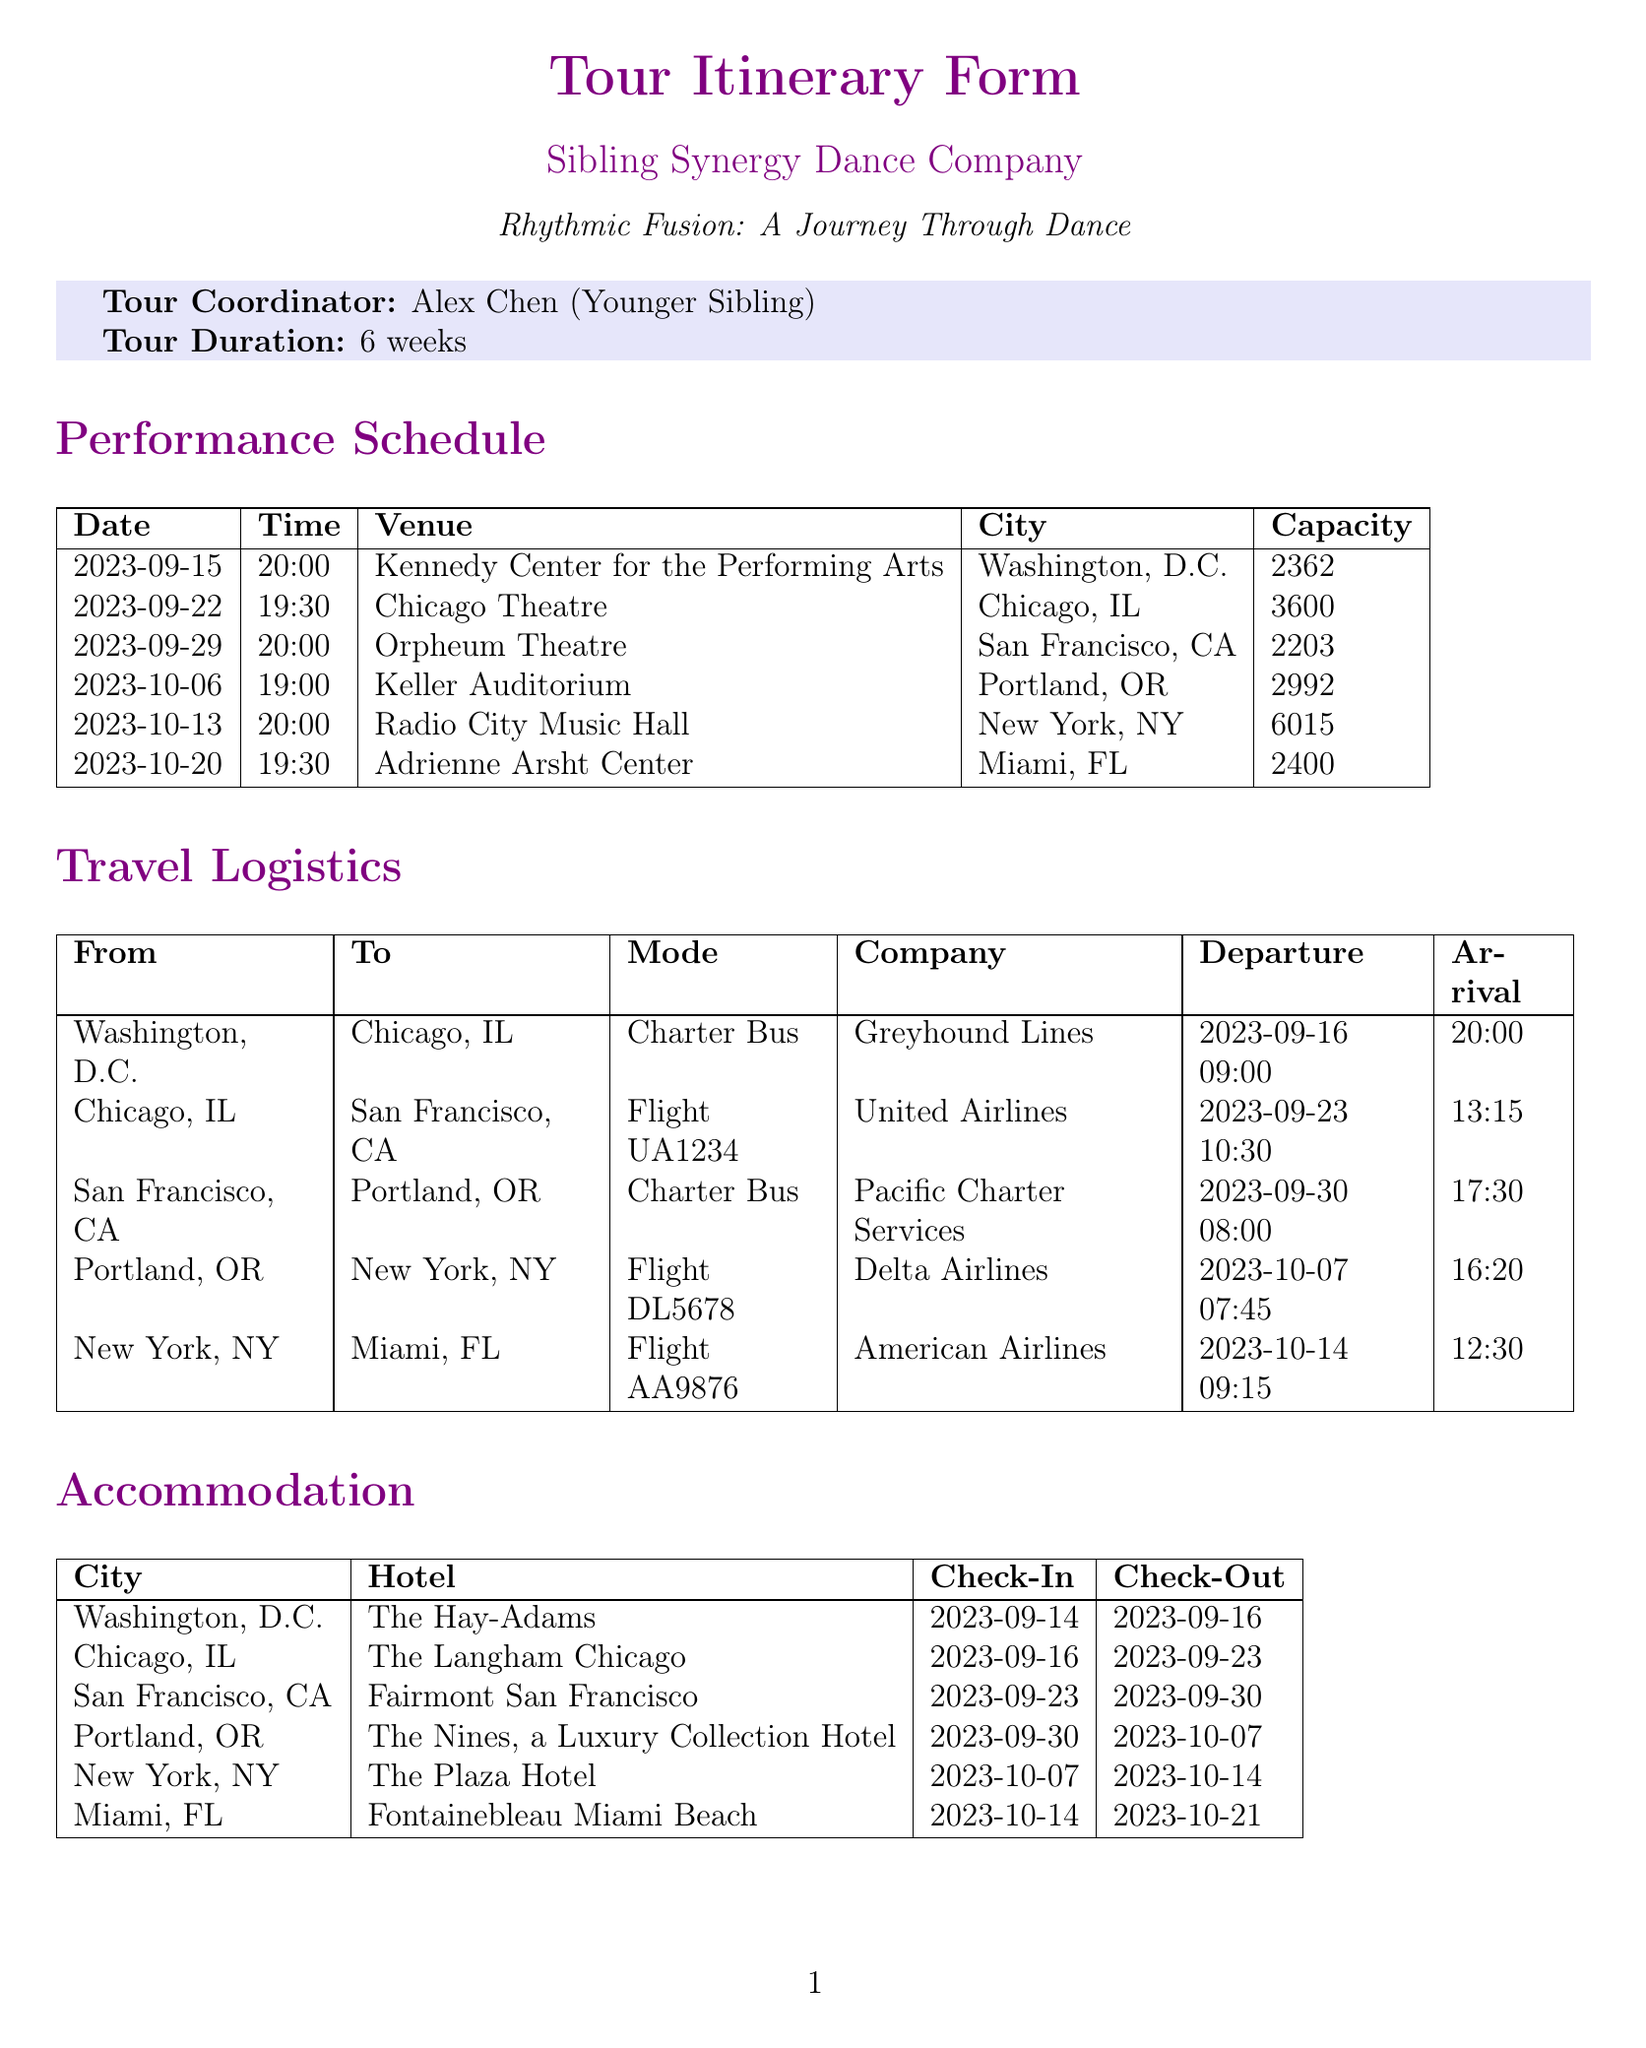what is the tour name? The tour name is specified at the beginning of the document, indicating the theme of the tour.
Answer: Rhythmic Fusion: A Journey Through Dance who is the tour coordinator? The tour coordinator's name is mentioned in the document as the individual responsible for coordinating the tour.
Answer: Alex Chen (Younger Sibling) how many performances are scheduled? The total number of performances can be counted from the performance schedule section of the document.
Answer: 6 what is the capacity of the venue in Miami? The capacity for the last performance listed provides the specific number of attendees the venue can accommodate.
Answer: 2400 what is the estimated arrival time from San Francisco to Portland? The estimated arrival time is provided in the travel logistics section, showing when the troupe is expected to arrive.
Answer: 17:30 how long will the troupe stay in New York? The check-in and check-out dates for New York can be calculated to determine the length of stay in that city.
Answer: 7 days which hotel will the troupe stay at in Chicago? The specific hotel where the troupe will be accommodated is listed under the accommodation section for Chicago.
Answer: The Langham Chicago what requirements are there for meal options? Special dietary needs are outlined in the special requirements section of the document, specifying the type of meal options needed.
Answer: Vegan and gluten-free meals for 3 dancers what transportation mode is used to travel from Washington, D.C. to Chicago? The mode of transportation is explicitly stated in the travel logistics section for this specific route.
Answer: Charter Bus 